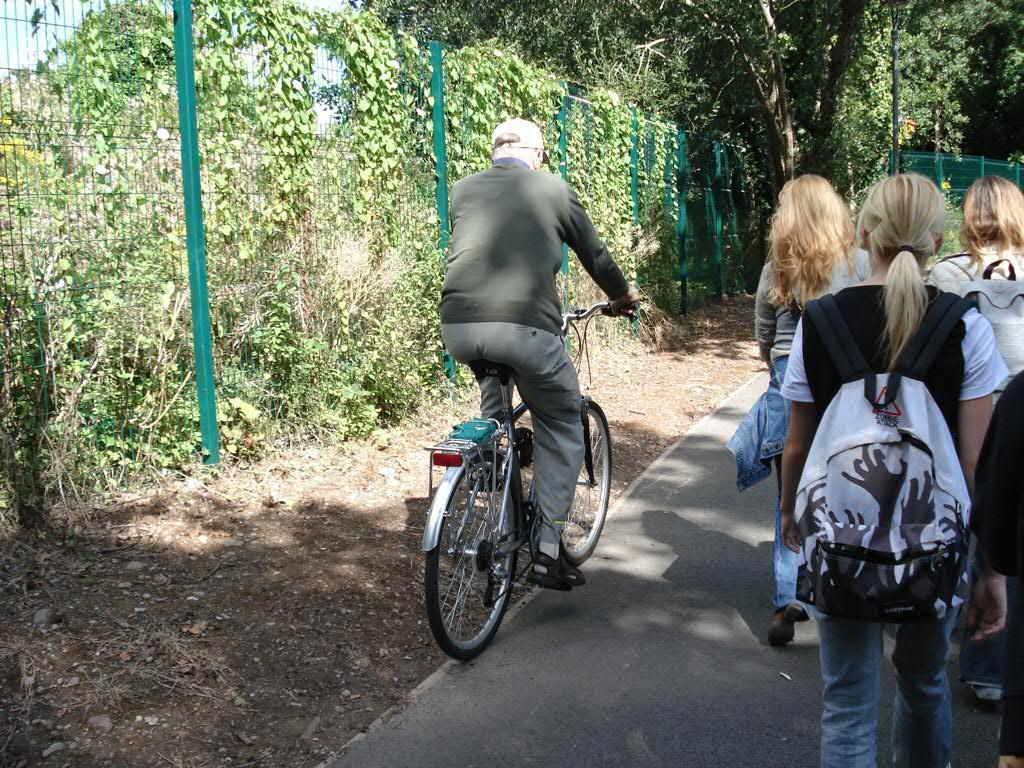What is the person in the image wearing on their head? The person in the image is wearing a hat. What activity is the person in the image engaged in? The person is riding a bicycle. Are there any other people present in the image? Yes, there is a group of people standing beside the person on the bicycle. What type of natural environment can be seen in the image? There are trees visible in the image. What type of barrier is present in the image? There is a green fence in the image. How many sheep can be seen grazing in the background of the image? There are no sheep present in the image. What type of water body can be seen in the image? There is no water body visible in the image. 